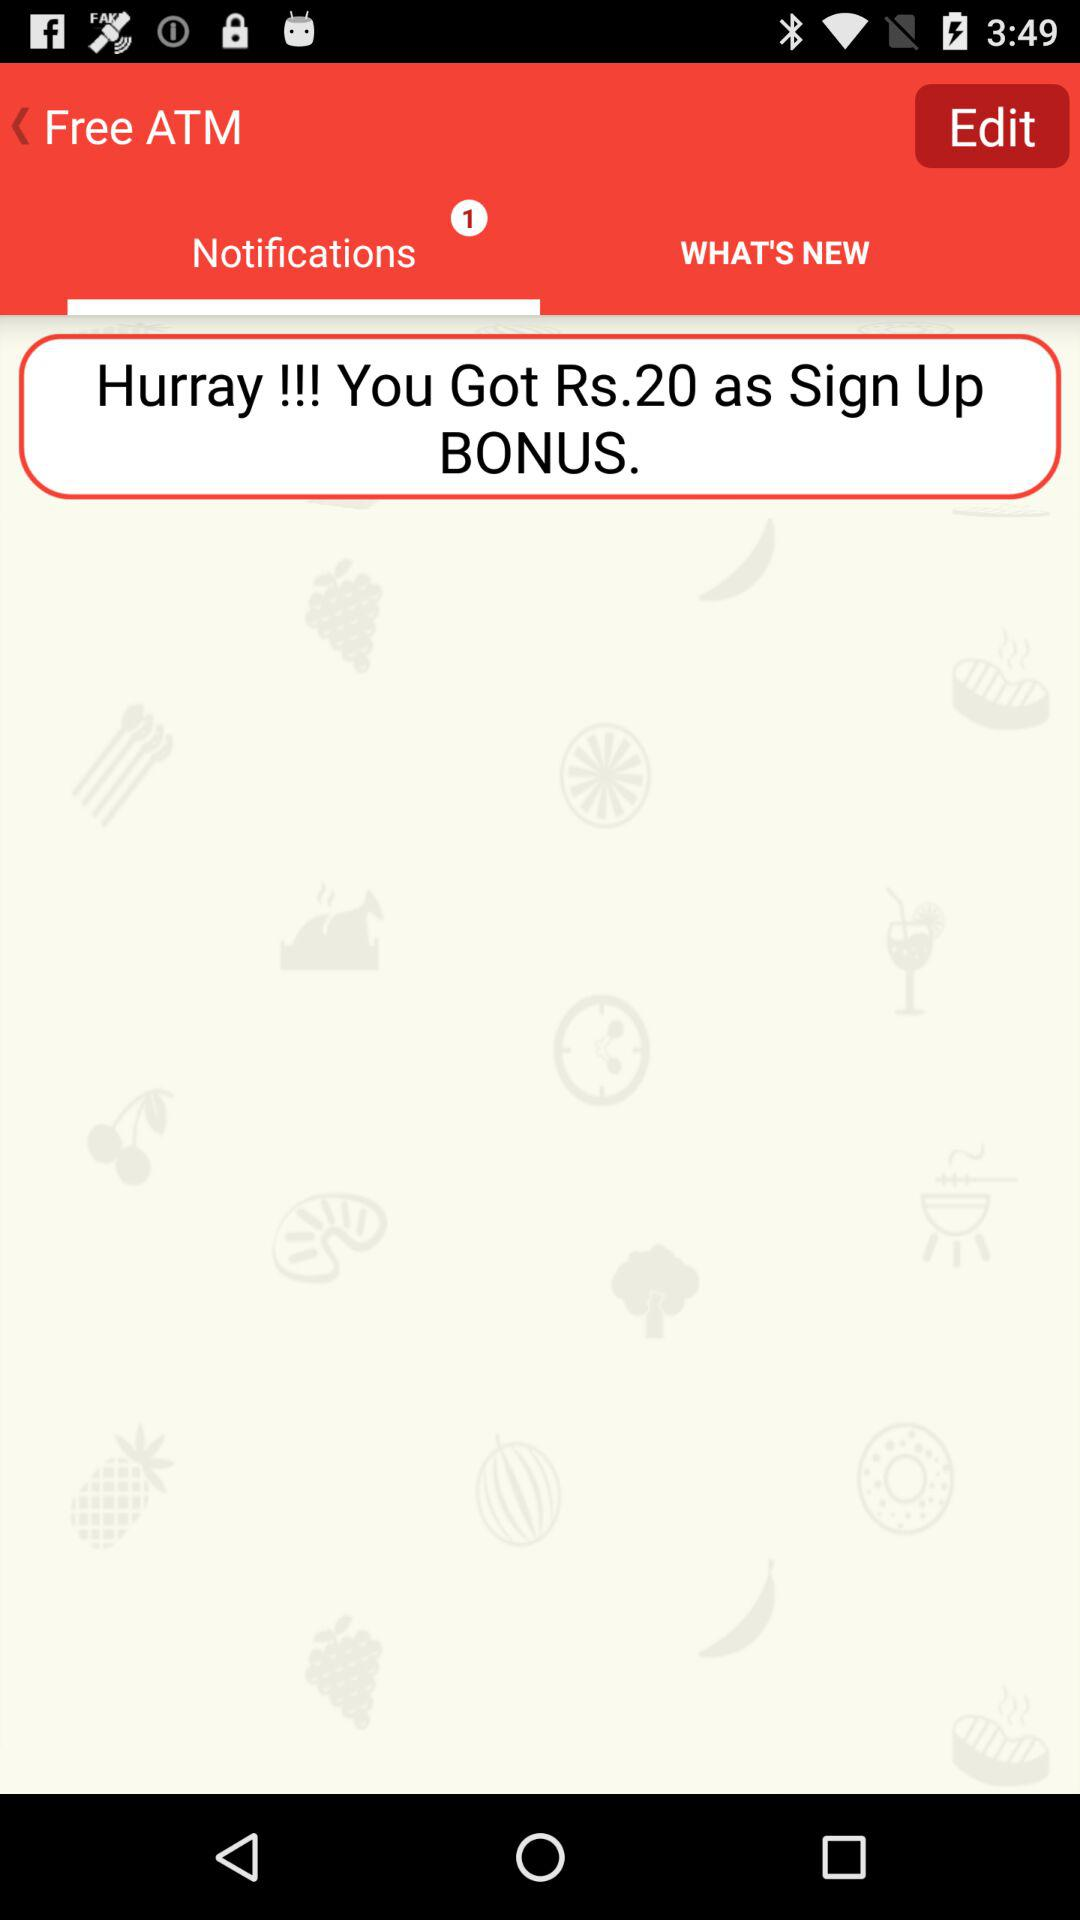How many notifications are there? There is 1 notification. 